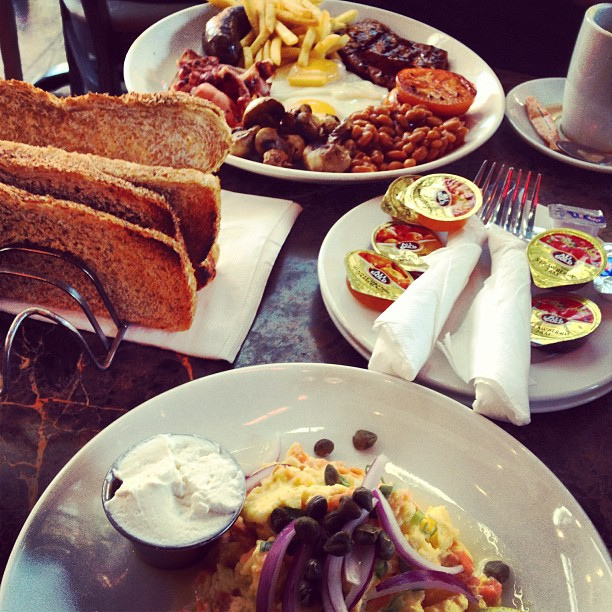What is on the plate with the two wrapped forks? The plate with the two wrapped forks contains several small containers of jelly or preserves. 